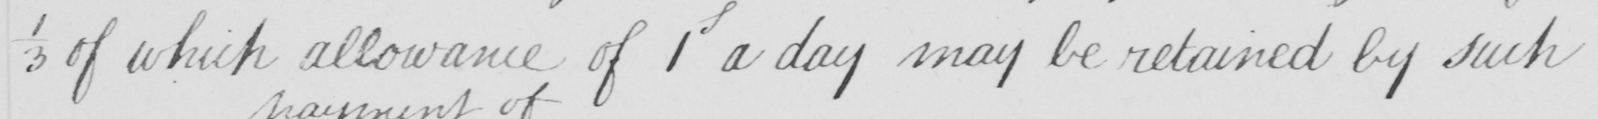What text is written in this handwritten line? 1/3 of which allowance of 1 a day may be retained by such 